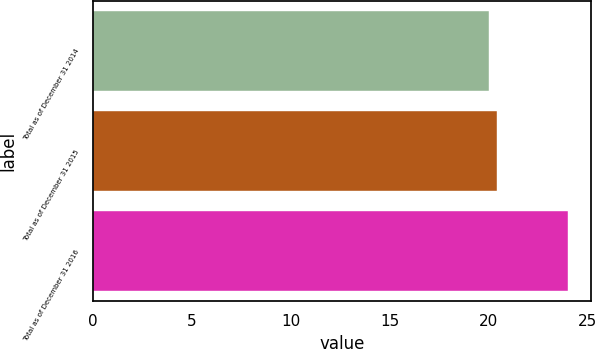<chart> <loc_0><loc_0><loc_500><loc_500><bar_chart><fcel>Total as of December 31 2014<fcel>Total as of December 31 2015<fcel>Total as of December 31 2016<nl><fcel>20<fcel>20.4<fcel>24<nl></chart> 